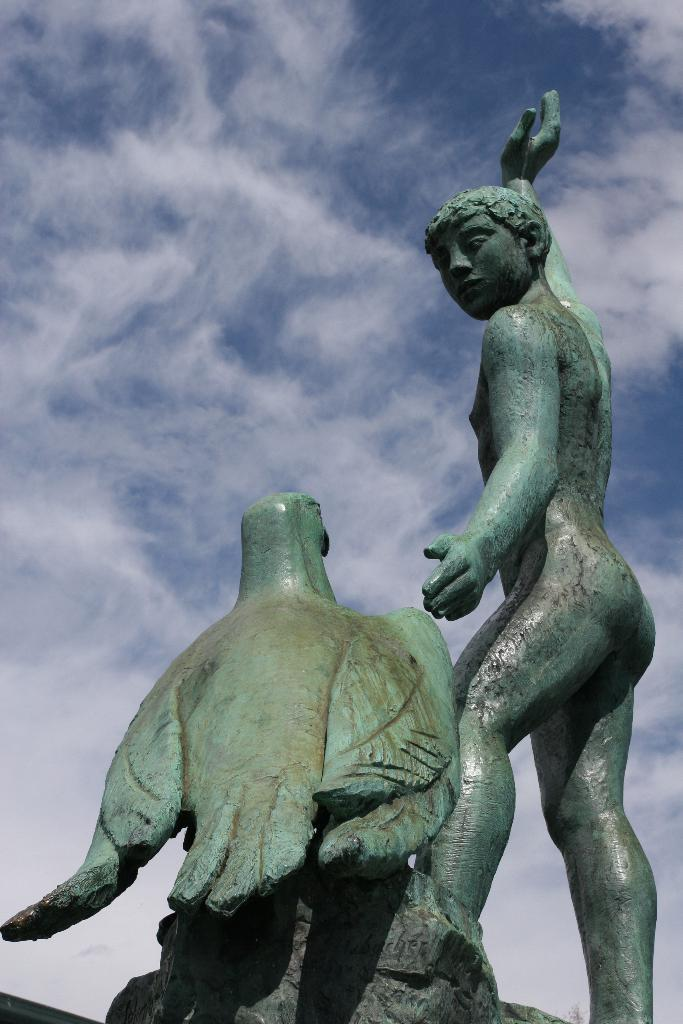What type of statues can be seen in the image? There is a statue of a man and a statue of a bird in the image. What is the color and condition of the sky in the image? The sky is blue and cloudy in the image. What type of line can be seen connecting the two statues in the image? There is no line connecting the two statues in the image. What historical event is depicted by the statues in the image? The statues in the image do not depict any specific historical event. 